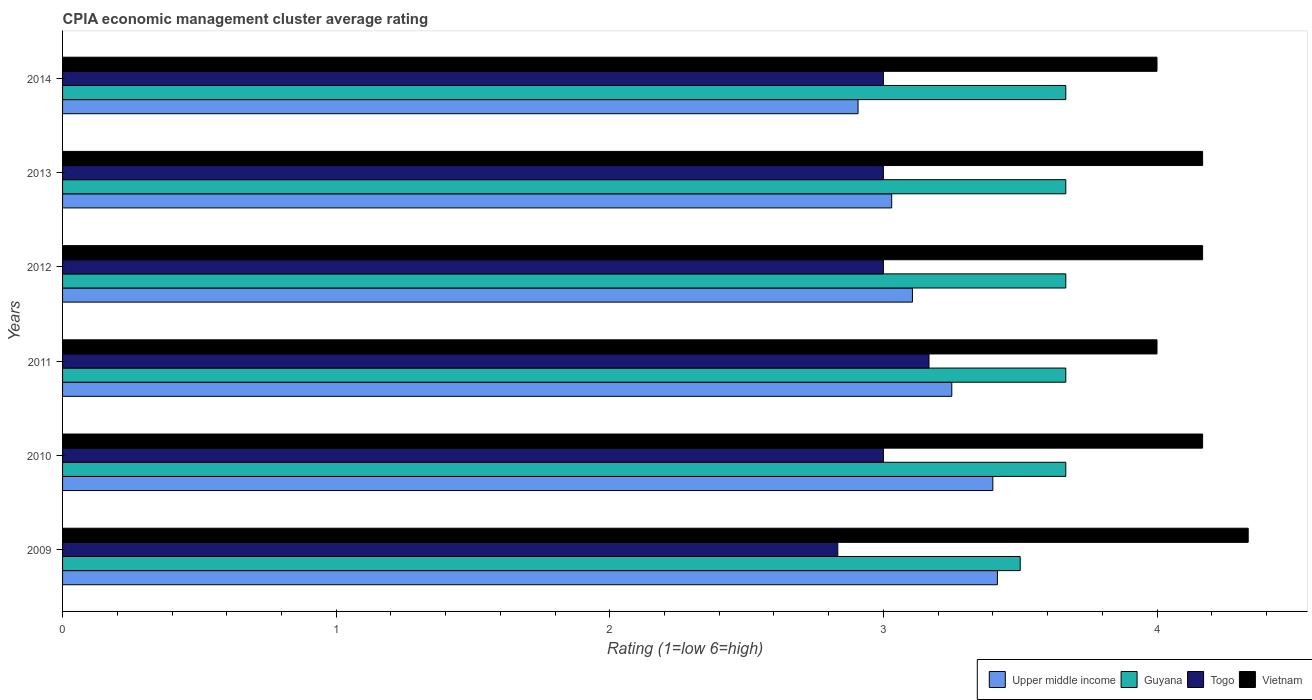Are the number of bars per tick equal to the number of legend labels?
Keep it short and to the point. Yes. Are the number of bars on each tick of the Y-axis equal?
Offer a terse response. Yes. How many bars are there on the 6th tick from the top?
Provide a short and direct response. 4. What is the label of the 3rd group of bars from the top?
Provide a succinct answer. 2012. What is the CPIA rating in Upper middle income in 2013?
Make the answer very short. 3.03. Across all years, what is the maximum CPIA rating in Guyana?
Ensure brevity in your answer.  3.67. Across all years, what is the minimum CPIA rating in Upper middle income?
Keep it short and to the point. 2.91. In which year was the CPIA rating in Togo maximum?
Your response must be concise. 2011. What is the total CPIA rating in Upper middle income in the graph?
Provide a short and direct response. 19.11. What is the difference between the CPIA rating in Upper middle income in 2010 and the CPIA rating in Vietnam in 2013?
Offer a terse response. -0.77. What is the average CPIA rating in Vietnam per year?
Provide a short and direct response. 4.14. In the year 2013, what is the difference between the CPIA rating in Togo and CPIA rating in Upper middle income?
Offer a terse response. -0.03. What is the ratio of the CPIA rating in Upper middle income in 2011 to that in 2014?
Your response must be concise. 1.12. Is the CPIA rating in Vietnam in 2009 less than that in 2011?
Your response must be concise. No. Is the difference between the CPIA rating in Togo in 2013 and 2014 greater than the difference between the CPIA rating in Upper middle income in 2013 and 2014?
Keep it short and to the point. No. What is the difference between the highest and the second highest CPIA rating in Togo?
Offer a terse response. 0.17. What is the difference between the highest and the lowest CPIA rating in Guyana?
Your answer should be very brief. 0.17. What does the 2nd bar from the top in 2010 represents?
Offer a terse response. Togo. What does the 1st bar from the bottom in 2009 represents?
Give a very brief answer. Upper middle income. How many bars are there?
Your answer should be compact. 24. Are all the bars in the graph horizontal?
Give a very brief answer. Yes. What is the difference between two consecutive major ticks on the X-axis?
Offer a very short reply. 1. Does the graph contain grids?
Provide a short and direct response. No. How are the legend labels stacked?
Your answer should be compact. Horizontal. What is the title of the graph?
Provide a succinct answer. CPIA economic management cluster average rating. Does "Senegal" appear as one of the legend labels in the graph?
Provide a short and direct response. No. What is the Rating (1=low 6=high) of Upper middle income in 2009?
Ensure brevity in your answer.  3.42. What is the Rating (1=low 6=high) in Guyana in 2009?
Give a very brief answer. 3.5. What is the Rating (1=low 6=high) in Togo in 2009?
Make the answer very short. 2.83. What is the Rating (1=low 6=high) in Vietnam in 2009?
Provide a succinct answer. 4.33. What is the Rating (1=low 6=high) in Guyana in 2010?
Provide a succinct answer. 3.67. What is the Rating (1=low 6=high) in Togo in 2010?
Provide a short and direct response. 3. What is the Rating (1=low 6=high) of Vietnam in 2010?
Your answer should be compact. 4.17. What is the Rating (1=low 6=high) in Upper middle income in 2011?
Provide a succinct answer. 3.25. What is the Rating (1=low 6=high) of Guyana in 2011?
Your answer should be compact. 3.67. What is the Rating (1=low 6=high) of Togo in 2011?
Provide a succinct answer. 3.17. What is the Rating (1=low 6=high) of Upper middle income in 2012?
Offer a very short reply. 3.11. What is the Rating (1=low 6=high) in Guyana in 2012?
Give a very brief answer. 3.67. What is the Rating (1=low 6=high) in Vietnam in 2012?
Offer a very short reply. 4.17. What is the Rating (1=low 6=high) of Upper middle income in 2013?
Your answer should be very brief. 3.03. What is the Rating (1=low 6=high) of Guyana in 2013?
Offer a very short reply. 3.67. What is the Rating (1=low 6=high) in Vietnam in 2013?
Give a very brief answer. 4.17. What is the Rating (1=low 6=high) in Upper middle income in 2014?
Keep it short and to the point. 2.91. What is the Rating (1=low 6=high) in Guyana in 2014?
Ensure brevity in your answer.  3.67. What is the Rating (1=low 6=high) of Togo in 2014?
Your answer should be very brief. 3. What is the Rating (1=low 6=high) in Vietnam in 2014?
Give a very brief answer. 4. Across all years, what is the maximum Rating (1=low 6=high) in Upper middle income?
Offer a very short reply. 3.42. Across all years, what is the maximum Rating (1=low 6=high) in Guyana?
Provide a short and direct response. 3.67. Across all years, what is the maximum Rating (1=low 6=high) of Togo?
Your answer should be compact. 3.17. Across all years, what is the maximum Rating (1=low 6=high) of Vietnam?
Your response must be concise. 4.33. Across all years, what is the minimum Rating (1=low 6=high) in Upper middle income?
Provide a short and direct response. 2.91. Across all years, what is the minimum Rating (1=low 6=high) of Guyana?
Your response must be concise. 3.5. Across all years, what is the minimum Rating (1=low 6=high) of Togo?
Offer a very short reply. 2.83. Across all years, what is the minimum Rating (1=low 6=high) of Vietnam?
Your answer should be compact. 4. What is the total Rating (1=low 6=high) of Upper middle income in the graph?
Your answer should be compact. 19.11. What is the total Rating (1=low 6=high) of Guyana in the graph?
Ensure brevity in your answer.  21.83. What is the total Rating (1=low 6=high) of Vietnam in the graph?
Ensure brevity in your answer.  24.83. What is the difference between the Rating (1=low 6=high) of Upper middle income in 2009 and that in 2010?
Give a very brief answer. 0.02. What is the difference between the Rating (1=low 6=high) in Guyana in 2009 and that in 2010?
Provide a succinct answer. -0.17. What is the difference between the Rating (1=low 6=high) of Vietnam in 2009 and that in 2010?
Provide a succinct answer. 0.17. What is the difference between the Rating (1=low 6=high) of Togo in 2009 and that in 2011?
Your answer should be compact. -0.33. What is the difference between the Rating (1=low 6=high) of Vietnam in 2009 and that in 2011?
Offer a terse response. 0.33. What is the difference between the Rating (1=low 6=high) in Upper middle income in 2009 and that in 2012?
Give a very brief answer. 0.31. What is the difference between the Rating (1=low 6=high) in Vietnam in 2009 and that in 2012?
Ensure brevity in your answer.  0.17. What is the difference between the Rating (1=low 6=high) in Upper middle income in 2009 and that in 2013?
Ensure brevity in your answer.  0.39. What is the difference between the Rating (1=low 6=high) in Guyana in 2009 and that in 2013?
Ensure brevity in your answer.  -0.17. What is the difference between the Rating (1=low 6=high) in Togo in 2009 and that in 2013?
Provide a succinct answer. -0.17. What is the difference between the Rating (1=low 6=high) of Upper middle income in 2009 and that in 2014?
Provide a succinct answer. 0.51. What is the difference between the Rating (1=low 6=high) of Guyana in 2009 and that in 2014?
Offer a very short reply. -0.17. What is the difference between the Rating (1=low 6=high) of Vietnam in 2009 and that in 2014?
Your answer should be very brief. 0.33. What is the difference between the Rating (1=low 6=high) of Upper middle income in 2010 and that in 2011?
Offer a very short reply. 0.15. What is the difference between the Rating (1=low 6=high) of Vietnam in 2010 and that in 2011?
Offer a terse response. 0.17. What is the difference between the Rating (1=low 6=high) in Upper middle income in 2010 and that in 2012?
Offer a very short reply. 0.29. What is the difference between the Rating (1=low 6=high) in Togo in 2010 and that in 2012?
Offer a very short reply. 0. What is the difference between the Rating (1=low 6=high) of Upper middle income in 2010 and that in 2013?
Provide a short and direct response. 0.37. What is the difference between the Rating (1=low 6=high) in Togo in 2010 and that in 2013?
Offer a terse response. 0. What is the difference between the Rating (1=low 6=high) of Vietnam in 2010 and that in 2013?
Your answer should be compact. 0. What is the difference between the Rating (1=low 6=high) in Upper middle income in 2010 and that in 2014?
Ensure brevity in your answer.  0.49. What is the difference between the Rating (1=low 6=high) in Guyana in 2010 and that in 2014?
Your answer should be very brief. -0. What is the difference between the Rating (1=low 6=high) of Vietnam in 2010 and that in 2014?
Your response must be concise. 0.17. What is the difference between the Rating (1=low 6=high) in Upper middle income in 2011 and that in 2012?
Your answer should be compact. 0.14. What is the difference between the Rating (1=low 6=high) in Togo in 2011 and that in 2012?
Ensure brevity in your answer.  0.17. What is the difference between the Rating (1=low 6=high) in Vietnam in 2011 and that in 2012?
Ensure brevity in your answer.  -0.17. What is the difference between the Rating (1=low 6=high) in Upper middle income in 2011 and that in 2013?
Offer a very short reply. 0.22. What is the difference between the Rating (1=low 6=high) in Upper middle income in 2011 and that in 2014?
Make the answer very short. 0.34. What is the difference between the Rating (1=low 6=high) in Guyana in 2011 and that in 2014?
Your answer should be compact. -0. What is the difference between the Rating (1=low 6=high) in Togo in 2011 and that in 2014?
Your answer should be compact. 0.17. What is the difference between the Rating (1=low 6=high) of Vietnam in 2011 and that in 2014?
Keep it short and to the point. 0. What is the difference between the Rating (1=low 6=high) in Upper middle income in 2012 and that in 2013?
Your answer should be very brief. 0.08. What is the difference between the Rating (1=low 6=high) in Upper middle income in 2012 and that in 2014?
Provide a succinct answer. 0.2. What is the difference between the Rating (1=low 6=high) in Guyana in 2012 and that in 2014?
Provide a short and direct response. -0. What is the difference between the Rating (1=low 6=high) of Togo in 2012 and that in 2014?
Provide a short and direct response. 0. What is the difference between the Rating (1=low 6=high) in Upper middle income in 2013 and that in 2014?
Your response must be concise. 0.12. What is the difference between the Rating (1=low 6=high) of Guyana in 2013 and that in 2014?
Ensure brevity in your answer.  -0. What is the difference between the Rating (1=low 6=high) of Togo in 2013 and that in 2014?
Keep it short and to the point. 0. What is the difference between the Rating (1=low 6=high) of Vietnam in 2013 and that in 2014?
Offer a terse response. 0.17. What is the difference between the Rating (1=low 6=high) in Upper middle income in 2009 and the Rating (1=low 6=high) in Guyana in 2010?
Your answer should be very brief. -0.25. What is the difference between the Rating (1=low 6=high) in Upper middle income in 2009 and the Rating (1=low 6=high) in Togo in 2010?
Ensure brevity in your answer.  0.42. What is the difference between the Rating (1=low 6=high) of Upper middle income in 2009 and the Rating (1=low 6=high) of Vietnam in 2010?
Make the answer very short. -0.75. What is the difference between the Rating (1=low 6=high) of Togo in 2009 and the Rating (1=low 6=high) of Vietnam in 2010?
Provide a short and direct response. -1.33. What is the difference between the Rating (1=low 6=high) in Upper middle income in 2009 and the Rating (1=low 6=high) in Guyana in 2011?
Give a very brief answer. -0.25. What is the difference between the Rating (1=low 6=high) in Upper middle income in 2009 and the Rating (1=low 6=high) in Vietnam in 2011?
Offer a terse response. -0.58. What is the difference between the Rating (1=low 6=high) in Guyana in 2009 and the Rating (1=low 6=high) in Vietnam in 2011?
Your response must be concise. -0.5. What is the difference between the Rating (1=low 6=high) of Togo in 2009 and the Rating (1=low 6=high) of Vietnam in 2011?
Offer a terse response. -1.17. What is the difference between the Rating (1=low 6=high) of Upper middle income in 2009 and the Rating (1=low 6=high) of Guyana in 2012?
Provide a short and direct response. -0.25. What is the difference between the Rating (1=low 6=high) of Upper middle income in 2009 and the Rating (1=low 6=high) of Togo in 2012?
Your answer should be compact. 0.42. What is the difference between the Rating (1=low 6=high) in Upper middle income in 2009 and the Rating (1=low 6=high) in Vietnam in 2012?
Offer a very short reply. -0.75. What is the difference between the Rating (1=low 6=high) of Guyana in 2009 and the Rating (1=low 6=high) of Togo in 2012?
Offer a very short reply. 0.5. What is the difference between the Rating (1=low 6=high) in Guyana in 2009 and the Rating (1=low 6=high) in Vietnam in 2012?
Your answer should be very brief. -0.67. What is the difference between the Rating (1=low 6=high) of Togo in 2009 and the Rating (1=low 6=high) of Vietnam in 2012?
Give a very brief answer. -1.33. What is the difference between the Rating (1=low 6=high) in Upper middle income in 2009 and the Rating (1=low 6=high) in Togo in 2013?
Make the answer very short. 0.42. What is the difference between the Rating (1=low 6=high) of Upper middle income in 2009 and the Rating (1=low 6=high) of Vietnam in 2013?
Offer a terse response. -0.75. What is the difference between the Rating (1=low 6=high) of Guyana in 2009 and the Rating (1=low 6=high) of Vietnam in 2013?
Keep it short and to the point. -0.67. What is the difference between the Rating (1=low 6=high) in Togo in 2009 and the Rating (1=low 6=high) in Vietnam in 2013?
Provide a succinct answer. -1.33. What is the difference between the Rating (1=low 6=high) in Upper middle income in 2009 and the Rating (1=low 6=high) in Togo in 2014?
Provide a short and direct response. 0.42. What is the difference between the Rating (1=low 6=high) in Upper middle income in 2009 and the Rating (1=low 6=high) in Vietnam in 2014?
Offer a very short reply. -0.58. What is the difference between the Rating (1=low 6=high) in Guyana in 2009 and the Rating (1=low 6=high) in Togo in 2014?
Ensure brevity in your answer.  0.5. What is the difference between the Rating (1=low 6=high) in Togo in 2009 and the Rating (1=low 6=high) in Vietnam in 2014?
Provide a short and direct response. -1.17. What is the difference between the Rating (1=low 6=high) of Upper middle income in 2010 and the Rating (1=low 6=high) of Guyana in 2011?
Provide a short and direct response. -0.27. What is the difference between the Rating (1=low 6=high) of Upper middle income in 2010 and the Rating (1=low 6=high) of Togo in 2011?
Provide a succinct answer. 0.23. What is the difference between the Rating (1=low 6=high) of Guyana in 2010 and the Rating (1=low 6=high) of Togo in 2011?
Your response must be concise. 0.5. What is the difference between the Rating (1=low 6=high) of Guyana in 2010 and the Rating (1=low 6=high) of Vietnam in 2011?
Your answer should be very brief. -0.33. What is the difference between the Rating (1=low 6=high) of Upper middle income in 2010 and the Rating (1=low 6=high) of Guyana in 2012?
Keep it short and to the point. -0.27. What is the difference between the Rating (1=low 6=high) in Upper middle income in 2010 and the Rating (1=low 6=high) in Togo in 2012?
Your answer should be very brief. 0.4. What is the difference between the Rating (1=low 6=high) of Upper middle income in 2010 and the Rating (1=low 6=high) of Vietnam in 2012?
Your answer should be compact. -0.77. What is the difference between the Rating (1=low 6=high) of Guyana in 2010 and the Rating (1=low 6=high) of Vietnam in 2012?
Offer a very short reply. -0.5. What is the difference between the Rating (1=low 6=high) in Togo in 2010 and the Rating (1=low 6=high) in Vietnam in 2012?
Your answer should be very brief. -1.17. What is the difference between the Rating (1=low 6=high) in Upper middle income in 2010 and the Rating (1=low 6=high) in Guyana in 2013?
Offer a very short reply. -0.27. What is the difference between the Rating (1=low 6=high) of Upper middle income in 2010 and the Rating (1=low 6=high) of Vietnam in 2013?
Provide a short and direct response. -0.77. What is the difference between the Rating (1=low 6=high) in Guyana in 2010 and the Rating (1=low 6=high) in Togo in 2013?
Provide a succinct answer. 0.67. What is the difference between the Rating (1=low 6=high) in Togo in 2010 and the Rating (1=low 6=high) in Vietnam in 2013?
Your response must be concise. -1.17. What is the difference between the Rating (1=low 6=high) in Upper middle income in 2010 and the Rating (1=low 6=high) in Guyana in 2014?
Ensure brevity in your answer.  -0.27. What is the difference between the Rating (1=low 6=high) of Upper middle income in 2010 and the Rating (1=low 6=high) of Togo in 2014?
Provide a succinct answer. 0.4. What is the difference between the Rating (1=low 6=high) of Upper middle income in 2010 and the Rating (1=low 6=high) of Vietnam in 2014?
Provide a succinct answer. -0.6. What is the difference between the Rating (1=low 6=high) in Guyana in 2010 and the Rating (1=low 6=high) in Vietnam in 2014?
Give a very brief answer. -0.33. What is the difference between the Rating (1=low 6=high) of Upper middle income in 2011 and the Rating (1=low 6=high) of Guyana in 2012?
Your response must be concise. -0.42. What is the difference between the Rating (1=low 6=high) in Upper middle income in 2011 and the Rating (1=low 6=high) in Togo in 2012?
Offer a terse response. 0.25. What is the difference between the Rating (1=low 6=high) of Upper middle income in 2011 and the Rating (1=low 6=high) of Vietnam in 2012?
Provide a short and direct response. -0.92. What is the difference between the Rating (1=low 6=high) in Togo in 2011 and the Rating (1=low 6=high) in Vietnam in 2012?
Make the answer very short. -1. What is the difference between the Rating (1=low 6=high) in Upper middle income in 2011 and the Rating (1=low 6=high) in Guyana in 2013?
Keep it short and to the point. -0.42. What is the difference between the Rating (1=low 6=high) of Upper middle income in 2011 and the Rating (1=low 6=high) of Vietnam in 2013?
Offer a terse response. -0.92. What is the difference between the Rating (1=low 6=high) of Guyana in 2011 and the Rating (1=low 6=high) of Togo in 2013?
Your answer should be very brief. 0.67. What is the difference between the Rating (1=low 6=high) of Guyana in 2011 and the Rating (1=low 6=high) of Vietnam in 2013?
Provide a succinct answer. -0.5. What is the difference between the Rating (1=low 6=high) of Togo in 2011 and the Rating (1=low 6=high) of Vietnam in 2013?
Keep it short and to the point. -1. What is the difference between the Rating (1=low 6=high) in Upper middle income in 2011 and the Rating (1=low 6=high) in Guyana in 2014?
Your answer should be compact. -0.42. What is the difference between the Rating (1=low 6=high) in Upper middle income in 2011 and the Rating (1=low 6=high) in Togo in 2014?
Your answer should be very brief. 0.25. What is the difference between the Rating (1=low 6=high) of Upper middle income in 2011 and the Rating (1=low 6=high) of Vietnam in 2014?
Provide a short and direct response. -0.75. What is the difference between the Rating (1=low 6=high) in Upper middle income in 2012 and the Rating (1=low 6=high) in Guyana in 2013?
Offer a terse response. -0.56. What is the difference between the Rating (1=low 6=high) in Upper middle income in 2012 and the Rating (1=low 6=high) in Togo in 2013?
Ensure brevity in your answer.  0.11. What is the difference between the Rating (1=low 6=high) in Upper middle income in 2012 and the Rating (1=low 6=high) in Vietnam in 2013?
Give a very brief answer. -1.06. What is the difference between the Rating (1=low 6=high) of Guyana in 2012 and the Rating (1=low 6=high) of Togo in 2013?
Ensure brevity in your answer.  0.67. What is the difference between the Rating (1=low 6=high) of Guyana in 2012 and the Rating (1=low 6=high) of Vietnam in 2013?
Provide a short and direct response. -0.5. What is the difference between the Rating (1=low 6=high) of Togo in 2012 and the Rating (1=low 6=high) of Vietnam in 2013?
Offer a terse response. -1.17. What is the difference between the Rating (1=low 6=high) in Upper middle income in 2012 and the Rating (1=low 6=high) in Guyana in 2014?
Your answer should be compact. -0.56. What is the difference between the Rating (1=low 6=high) of Upper middle income in 2012 and the Rating (1=low 6=high) of Togo in 2014?
Offer a very short reply. 0.11. What is the difference between the Rating (1=low 6=high) in Upper middle income in 2012 and the Rating (1=low 6=high) in Vietnam in 2014?
Offer a terse response. -0.89. What is the difference between the Rating (1=low 6=high) of Guyana in 2012 and the Rating (1=low 6=high) of Vietnam in 2014?
Ensure brevity in your answer.  -0.33. What is the difference between the Rating (1=low 6=high) of Upper middle income in 2013 and the Rating (1=low 6=high) of Guyana in 2014?
Give a very brief answer. -0.64. What is the difference between the Rating (1=low 6=high) in Upper middle income in 2013 and the Rating (1=low 6=high) in Togo in 2014?
Provide a succinct answer. 0.03. What is the difference between the Rating (1=low 6=high) of Upper middle income in 2013 and the Rating (1=low 6=high) of Vietnam in 2014?
Offer a very short reply. -0.97. What is the difference between the Rating (1=low 6=high) in Guyana in 2013 and the Rating (1=low 6=high) in Togo in 2014?
Offer a terse response. 0.67. What is the difference between the Rating (1=low 6=high) in Guyana in 2013 and the Rating (1=low 6=high) in Vietnam in 2014?
Your answer should be compact. -0.33. What is the average Rating (1=low 6=high) of Upper middle income per year?
Provide a short and direct response. 3.19. What is the average Rating (1=low 6=high) of Guyana per year?
Keep it short and to the point. 3.64. What is the average Rating (1=low 6=high) of Togo per year?
Your answer should be very brief. 3. What is the average Rating (1=low 6=high) of Vietnam per year?
Make the answer very short. 4.14. In the year 2009, what is the difference between the Rating (1=low 6=high) of Upper middle income and Rating (1=low 6=high) of Guyana?
Offer a very short reply. -0.08. In the year 2009, what is the difference between the Rating (1=low 6=high) in Upper middle income and Rating (1=low 6=high) in Togo?
Provide a succinct answer. 0.58. In the year 2009, what is the difference between the Rating (1=low 6=high) in Upper middle income and Rating (1=low 6=high) in Vietnam?
Provide a short and direct response. -0.92. In the year 2009, what is the difference between the Rating (1=low 6=high) of Guyana and Rating (1=low 6=high) of Togo?
Provide a succinct answer. 0.67. In the year 2009, what is the difference between the Rating (1=low 6=high) of Guyana and Rating (1=low 6=high) of Vietnam?
Keep it short and to the point. -0.83. In the year 2010, what is the difference between the Rating (1=low 6=high) of Upper middle income and Rating (1=low 6=high) of Guyana?
Your answer should be very brief. -0.27. In the year 2010, what is the difference between the Rating (1=low 6=high) in Upper middle income and Rating (1=low 6=high) in Vietnam?
Your answer should be compact. -0.77. In the year 2010, what is the difference between the Rating (1=low 6=high) in Guyana and Rating (1=low 6=high) in Togo?
Offer a terse response. 0.67. In the year 2010, what is the difference between the Rating (1=low 6=high) of Togo and Rating (1=low 6=high) of Vietnam?
Provide a succinct answer. -1.17. In the year 2011, what is the difference between the Rating (1=low 6=high) of Upper middle income and Rating (1=low 6=high) of Guyana?
Provide a short and direct response. -0.42. In the year 2011, what is the difference between the Rating (1=low 6=high) in Upper middle income and Rating (1=low 6=high) in Togo?
Your answer should be compact. 0.08. In the year 2011, what is the difference between the Rating (1=low 6=high) of Upper middle income and Rating (1=low 6=high) of Vietnam?
Keep it short and to the point. -0.75. In the year 2011, what is the difference between the Rating (1=low 6=high) of Guyana and Rating (1=low 6=high) of Vietnam?
Make the answer very short. -0.33. In the year 2011, what is the difference between the Rating (1=low 6=high) in Togo and Rating (1=low 6=high) in Vietnam?
Keep it short and to the point. -0.83. In the year 2012, what is the difference between the Rating (1=low 6=high) of Upper middle income and Rating (1=low 6=high) of Guyana?
Provide a short and direct response. -0.56. In the year 2012, what is the difference between the Rating (1=low 6=high) in Upper middle income and Rating (1=low 6=high) in Togo?
Your response must be concise. 0.11. In the year 2012, what is the difference between the Rating (1=low 6=high) in Upper middle income and Rating (1=low 6=high) in Vietnam?
Ensure brevity in your answer.  -1.06. In the year 2012, what is the difference between the Rating (1=low 6=high) of Guyana and Rating (1=low 6=high) of Togo?
Offer a very short reply. 0.67. In the year 2012, what is the difference between the Rating (1=low 6=high) in Togo and Rating (1=low 6=high) in Vietnam?
Your response must be concise. -1.17. In the year 2013, what is the difference between the Rating (1=low 6=high) in Upper middle income and Rating (1=low 6=high) in Guyana?
Give a very brief answer. -0.64. In the year 2013, what is the difference between the Rating (1=low 6=high) of Upper middle income and Rating (1=low 6=high) of Togo?
Give a very brief answer. 0.03. In the year 2013, what is the difference between the Rating (1=low 6=high) of Upper middle income and Rating (1=low 6=high) of Vietnam?
Your answer should be very brief. -1.14. In the year 2013, what is the difference between the Rating (1=low 6=high) of Guyana and Rating (1=low 6=high) of Togo?
Your answer should be compact. 0.67. In the year 2013, what is the difference between the Rating (1=low 6=high) of Togo and Rating (1=low 6=high) of Vietnam?
Ensure brevity in your answer.  -1.17. In the year 2014, what is the difference between the Rating (1=low 6=high) of Upper middle income and Rating (1=low 6=high) of Guyana?
Provide a succinct answer. -0.76. In the year 2014, what is the difference between the Rating (1=low 6=high) of Upper middle income and Rating (1=low 6=high) of Togo?
Offer a terse response. -0.09. In the year 2014, what is the difference between the Rating (1=low 6=high) of Upper middle income and Rating (1=low 6=high) of Vietnam?
Provide a succinct answer. -1.09. What is the ratio of the Rating (1=low 6=high) of Upper middle income in 2009 to that in 2010?
Your response must be concise. 1. What is the ratio of the Rating (1=low 6=high) of Guyana in 2009 to that in 2010?
Your answer should be compact. 0.95. What is the ratio of the Rating (1=low 6=high) in Vietnam in 2009 to that in 2010?
Your response must be concise. 1.04. What is the ratio of the Rating (1=low 6=high) in Upper middle income in 2009 to that in 2011?
Your answer should be very brief. 1.05. What is the ratio of the Rating (1=low 6=high) of Guyana in 2009 to that in 2011?
Your answer should be very brief. 0.95. What is the ratio of the Rating (1=low 6=high) of Togo in 2009 to that in 2011?
Offer a terse response. 0.89. What is the ratio of the Rating (1=low 6=high) in Vietnam in 2009 to that in 2011?
Provide a short and direct response. 1.08. What is the ratio of the Rating (1=low 6=high) in Upper middle income in 2009 to that in 2012?
Your answer should be compact. 1.1. What is the ratio of the Rating (1=low 6=high) of Guyana in 2009 to that in 2012?
Your answer should be compact. 0.95. What is the ratio of the Rating (1=low 6=high) of Togo in 2009 to that in 2012?
Your response must be concise. 0.94. What is the ratio of the Rating (1=low 6=high) in Upper middle income in 2009 to that in 2013?
Make the answer very short. 1.13. What is the ratio of the Rating (1=low 6=high) of Guyana in 2009 to that in 2013?
Provide a short and direct response. 0.95. What is the ratio of the Rating (1=low 6=high) of Vietnam in 2009 to that in 2013?
Offer a terse response. 1.04. What is the ratio of the Rating (1=low 6=high) of Upper middle income in 2009 to that in 2014?
Ensure brevity in your answer.  1.18. What is the ratio of the Rating (1=low 6=high) in Guyana in 2009 to that in 2014?
Your response must be concise. 0.95. What is the ratio of the Rating (1=low 6=high) in Vietnam in 2009 to that in 2014?
Provide a succinct answer. 1.08. What is the ratio of the Rating (1=low 6=high) of Upper middle income in 2010 to that in 2011?
Give a very brief answer. 1.05. What is the ratio of the Rating (1=low 6=high) in Guyana in 2010 to that in 2011?
Your answer should be very brief. 1. What is the ratio of the Rating (1=low 6=high) of Togo in 2010 to that in 2011?
Keep it short and to the point. 0.95. What is the ratio of the Rating (1=low 6=high) in Vietnam in 2010 to that in 2011?
Make the answer very short. 1.04. What is the ratio of the Rating (1=low 6=high) of Upper middle income in 2010 to that in 2012?
Your response must be concise. 1.09. What is the ratio of the Rating (1=low 6=high) in Togo in 2010 to that in 2012?
Offer a very short reply. 1. What is the ratio of the Rating (1=low 6=high) in Upper middle income in 2010 to that in 2013?
Ensure brevity in your answer.  1.12. What is the ratio of the Rating (1=low 6=high) of Togo in 2010 to that in 2013?
Offer a terse response. 1. What is the ratio of the Rating (1=low 6=high) of Upper middle income in 2010 to that in 2014?
Your answer should be very brief. 1.17. What is the ratio of the Rating (1=low 6=high) in Vietnam in 2010 to that in 2014?
Your response must be concise. 1.04. What is the ratio of the Rating (1=low 6=high) in Upper middle income in 2011 to that in 2012?
Give a very brief answer. 1.05. What is the ratio of the Rating (1=low 6=high) in Togo in 2011 to that in 2012?
Give a very brief answer. 1.06. What is the ratio of the Rating (1=low 6=high) of Vietnam in 2011 to that in 2012?
Make the answer very short. 0.96. What is the ratio of the Rating (1=low 6=high) of Upper middle income in 2011 to that in 2013?
Keep it short and to the point. 1.07. What is the ratio of the Rating (1=low 6=high) in Togo in 2011 to that in 2013?
Your answer should be very brief. 1.06. What is the ratio of the Rating (1=low 6=high) in Upper middle income in 2011 to that in 2014?
Provide a short and direct response. 1.12. What is the ratio of the Rating (1=low 6=high) of Guyana in 2011 to that in 2014?
Offer a terse response. 1. What is the ratio of the Rating (1=low 6=high) of Togo in 2011 to that in 2014?
Your response must be concise. 1.06. What is the ratio of the Rating (1=low 6=high) in Vietnam in 2011 to that in 2014?
Make the answer very short. 1. What is the ratio of the Rating (1=low 6=high) in Togo in 2012 to that in 2013?
Your answer should be compact. 1. What is the ratio of the Rating (1=low 6=high) of Upper middle income in 2012 to that in 2014?
Ensure brevity in your answer.  1.07. What is the ratio of the Rating (1=low 6=high) in Vietnam in 2012 to that in 2014?
Offer a very short reply. 1.04. What is the ratio of the Rating (1=low 6=high) of Upper middle income in 2013 to that in 2014?
Your response must be concise. 1.04. What is the ratio of the Rating (1=low 6=high) in Togo in 2013 to that in 2014?
Make the answer very short. 1. What is the ratio of the Rating (1=low 6=high) of Vietnam in 2013 to that in 2014?
Make the answer very short. 1.04. What is the difference between the highest and the second highest Rating (1=low 6=high) in Upper middle income?
Offer a very short reply. 0.02. What is the difference between the highest and the lowest Rating (1=low 6=high) in Upper middle income?
Offer a very short reply. 0.51. What is the difference between the highest and the lowest Rating (1=low 6=high) of Guyana?
Provide a short and direct response. 0.17. What is the difference between the highest and the lowest Rating (1=low 6=high) in Togo?
Ensure brevity in your answer.  0.33. What is the difference between the highest and the lowest Rating (1=low 6=high) of Vietnam?
Keep it short and to the point. 0.33. 